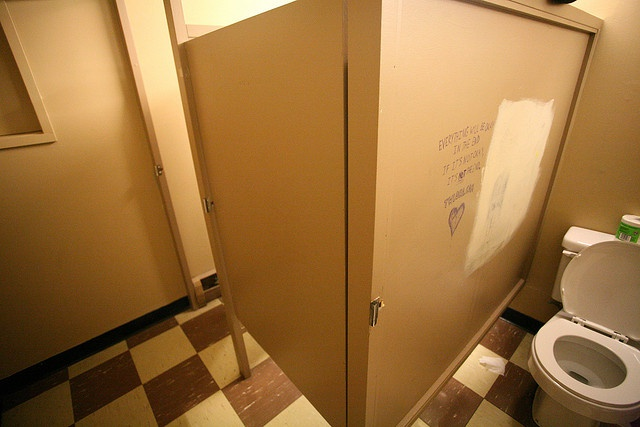Describe the objects in this image and their specific colors. I can see a toilet in maroon, gray, olive, and tan tones in this image. 